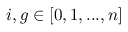<formula> <loc_0><loc_0><loc_500><loc_500>{ i , g } \in [ 0 , 1 , \dots , n ]</formula> 